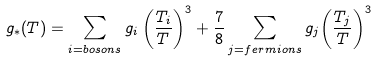<formula> <loc_0><loc_0><loc_500><loc_500>g _ { * } ( T ) = \sum _ { i = b o s o n s } g _ { i } \left ( { \frac { T _ { i } } { T } } \right ) ^ { 3 } + { \frac { 7 } { 8 } } \sum _ { j = f e r m i o n s } g _ { j } { \left ( { \frac { T _ { j } } { T } } \right ) } ^ { 3 }</formula> 